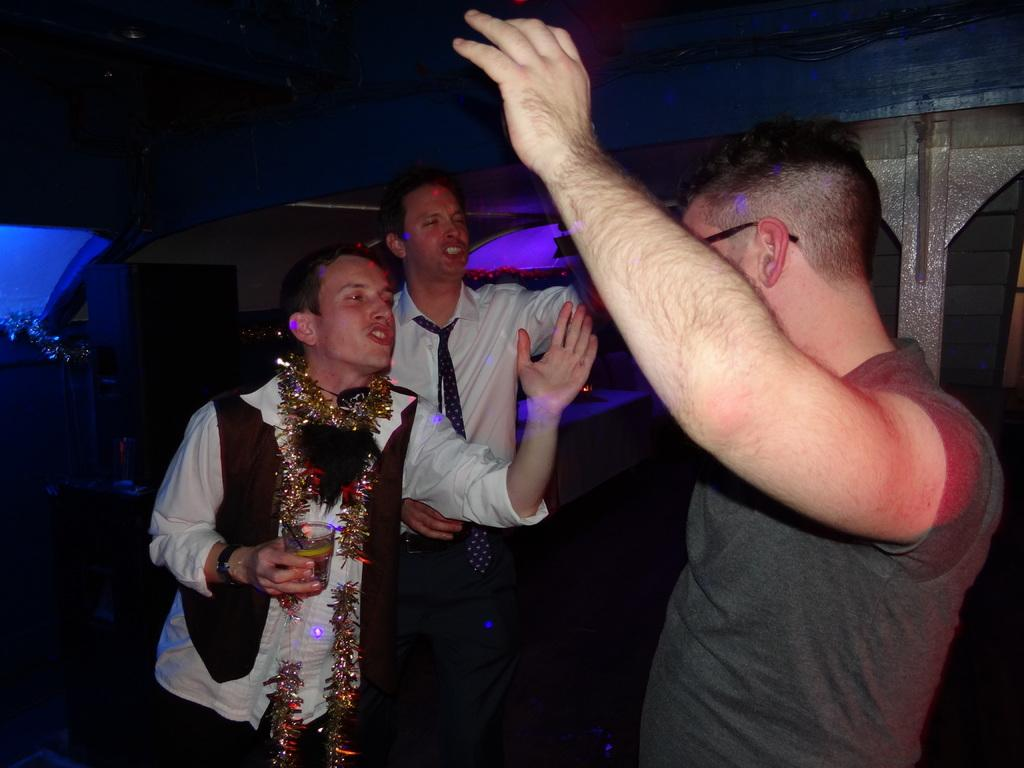How many people are in the image? There are three people in the image. What is one person holding in the image? One person is holding a glass containing a drink. What can be seen behind the people in the image? There is a wall visible behind the people. Are there any cobwebs visible in the image? There is no mention of cobwebs in the provided facts, so we cannot determine if any are present in the image. 